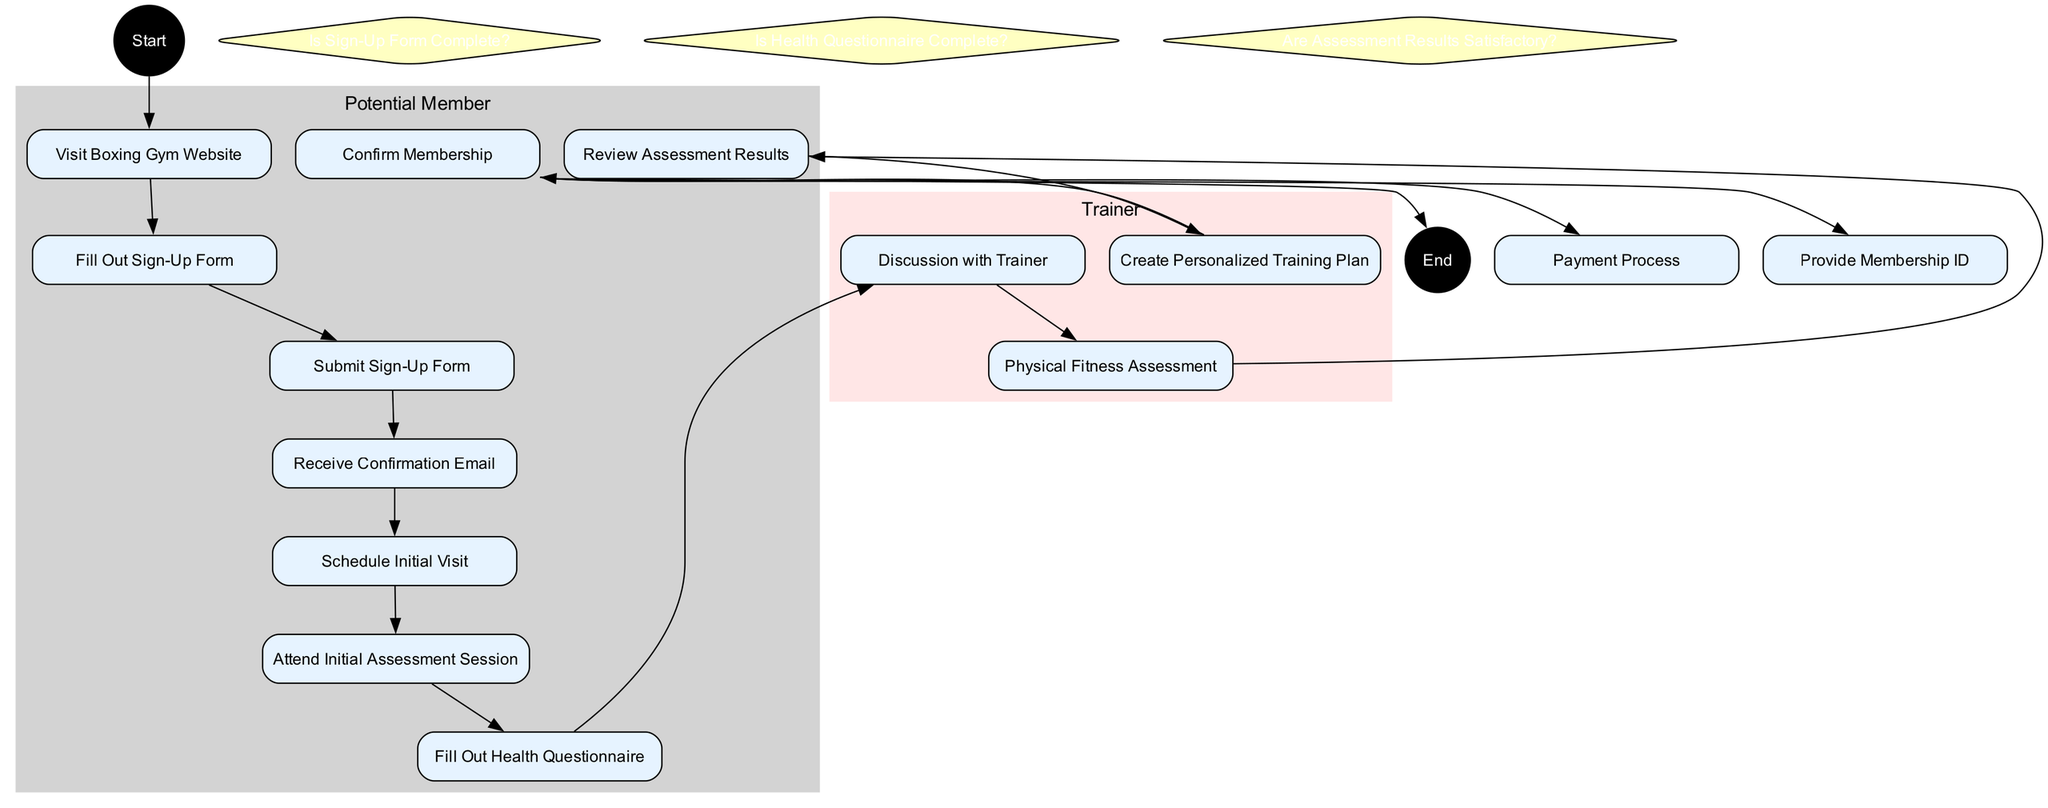What is the starting point of the diagram? The starting point is indicated as "Potential Member Interested" which is the first activity that initiates the process.
Answer: Potential Member Interested How many activities are listed in total? Counting all the activities mentioned, we can see there are 12 distinct activities that comprise the member sign-up process and initial assessment.
Answer: 12 Which activity follows after "Submit Sign-Up Form"? The diagram describes a flow where after "Submit Sign-Up Form," the next activity is "Receive Confirmation Email," following the indicated sequence in the sign-up process.
Answer: Receive Confirmation Email What decision point checks for the completion of the health questionnaire? The decision point that specifically asks about the health questionnaire is labeled "Is Health Questionnaire Complete?" which serves as a checkpoint in the flow.
Answer: Is Health Questionnaire Complete? What are the two parallel activities that occur after confirming membership? The diagram indicates that after "Confirm Membership," two parallel activities occur which are "Payment Process" and "Provide Membership ID," meaning these tasks are carried out simultaneously.
Answer: Payment Process, Provide Membership ID Are there activities listed under the Trainer's swimlane? Yes, the Trainer's swimlane includes three activities: "Discussion with Trainer," "Physical Fitness Assessment," and "Create Personalized Training Plan," all of which pertain to the Trainer’s role in the assessment process.
Answer: Yes What is the end point of the diagram? The endpoint of the member sign-up process is clearly stated as "Membership Confirmed," indicating successful completion.
Answer: Membership Confirmed Is there an activity for filling out a health questionnaire? Yes, "Fill Out Health Questionnaire" is one of the activities that the potential member must complete as part of the sign-up process before proceeding to the initial assessment.
Answer: Yes How many decision points are present in the diagram? The diagram contains three decision points that guide the flow of activities based on certain criteria, specifically regarding the sign-up and assessment process.
Answer: 3 